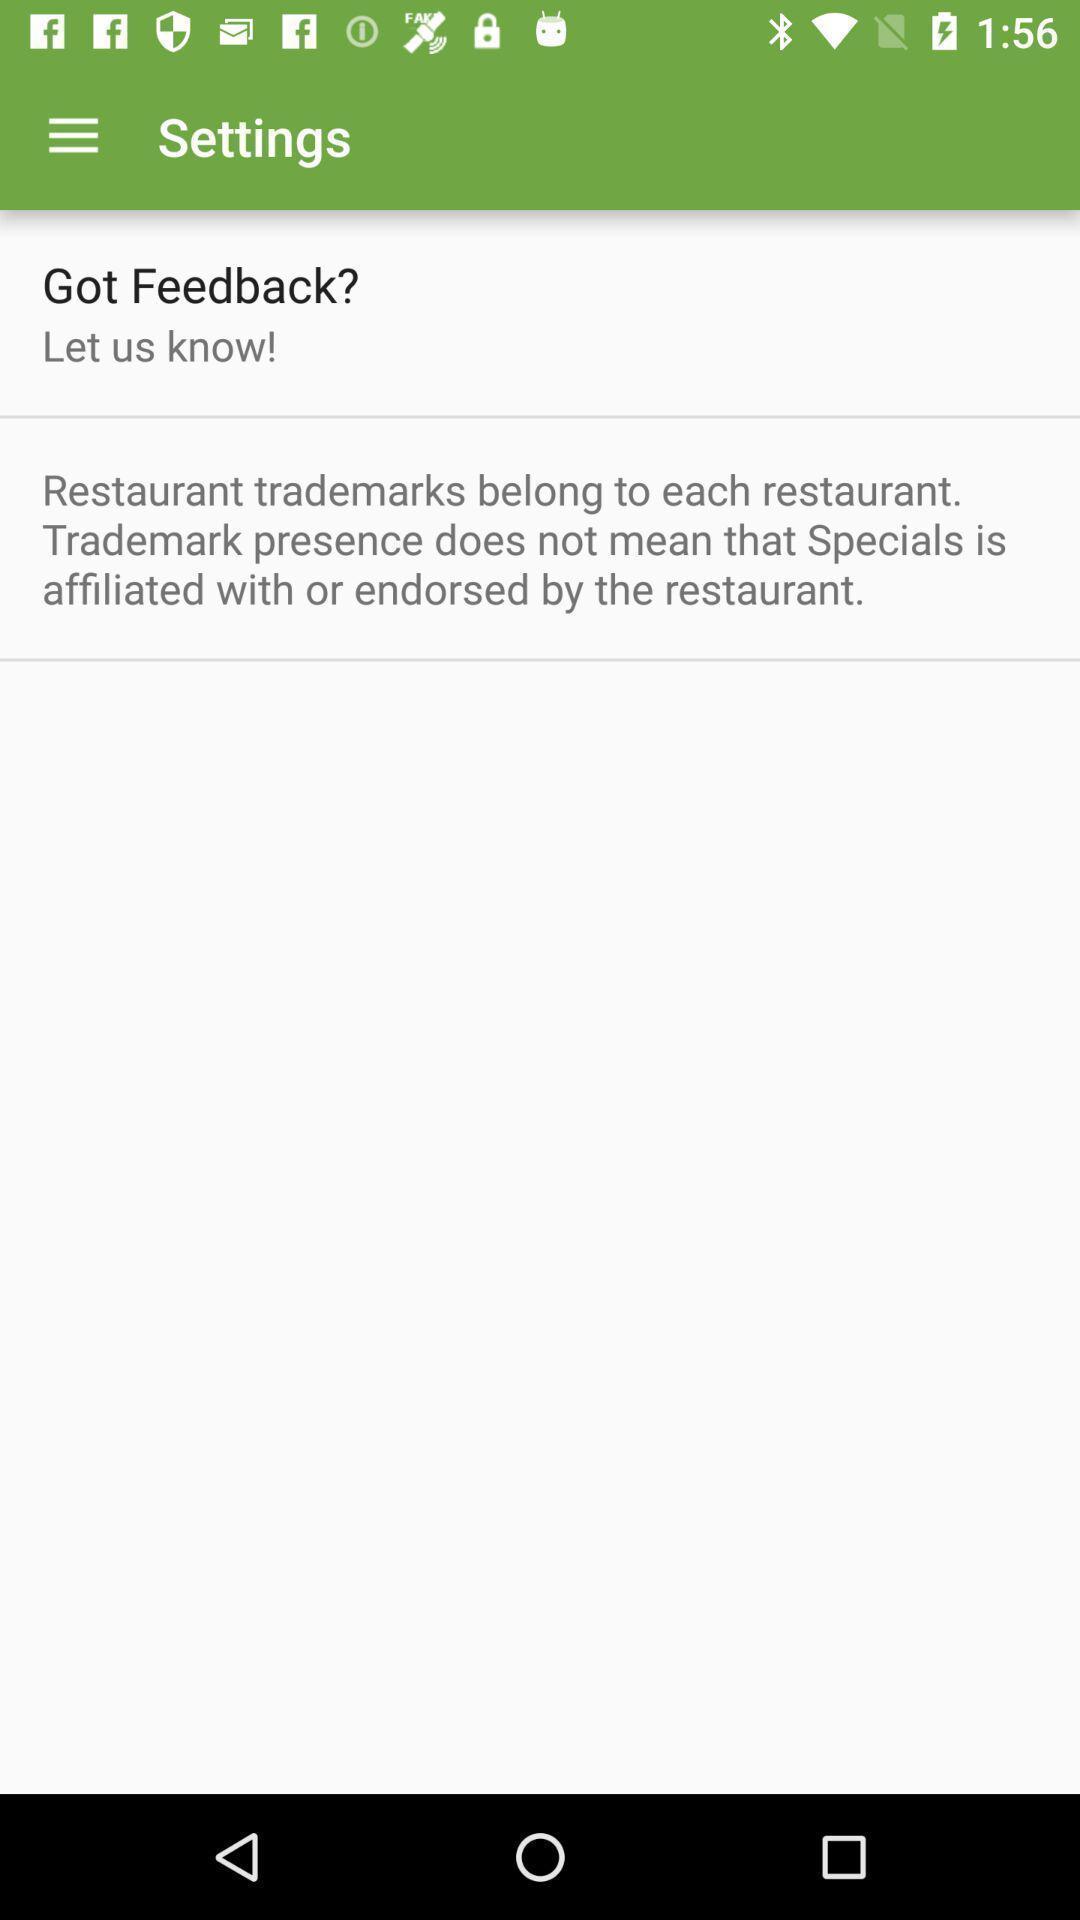Give me a narrative description of this picture. Screen displaying contents in settings page. 